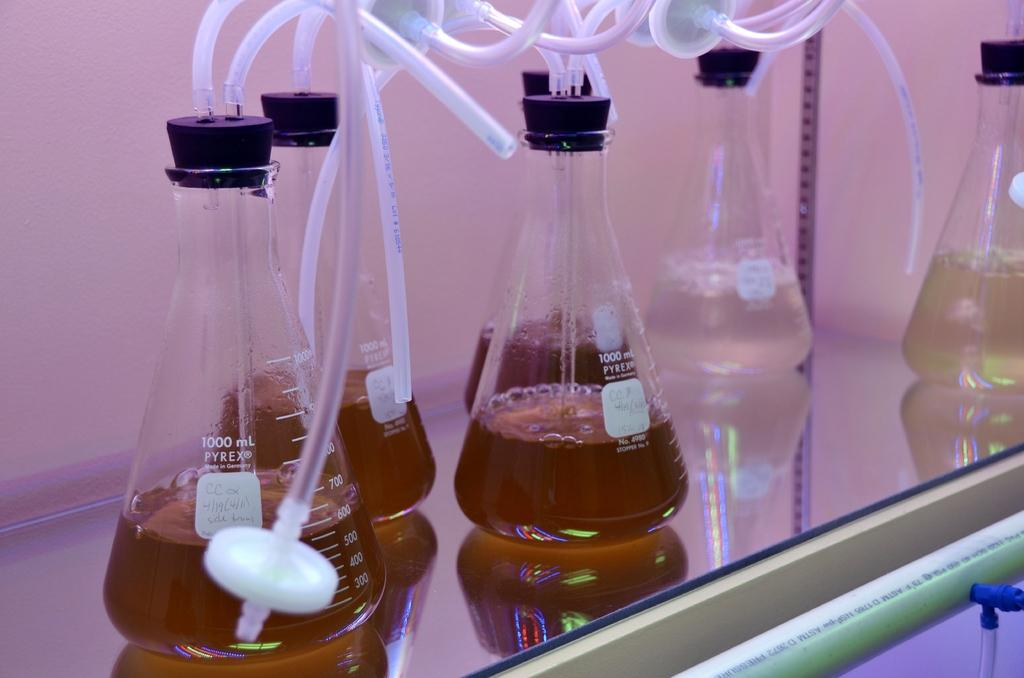<image>
Relay a brief, clear account of the picture shown. Six Pyrex Vials with different tubes running in and out of them. 